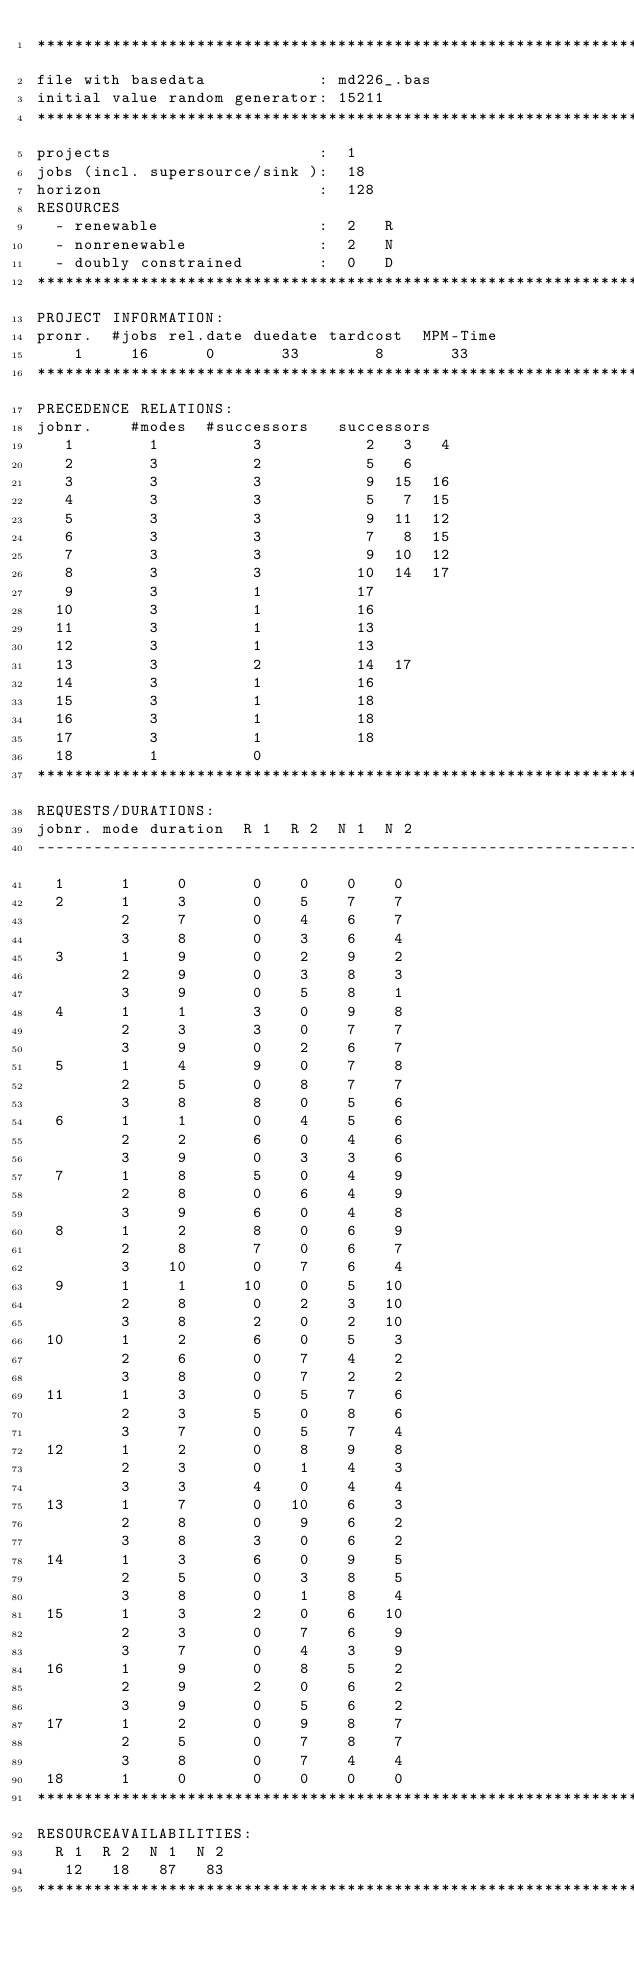<code> <loc_0><loc_0><loc_500><loc_500><_ObjectiveC_>************************************************************************
file with basedata            : md226_.bas
initial value random generator: 15211
************************************************************************
projects                      :  1
jobs (incl. supersource/sink ):  18
horizon                       :  128
RESOURCES
  - renewable                 :  2   R
  - nonrenewable              :  2   N
  - doubly constrained        :  0   D
************************************************************************
PROJECT INFORMATION:
pronr.  #jobs rel.date duedate tardcost  MPM-Time
    1     16      0       33        8       33
************************************************************************
PRECEDENCE RELATIONS:
jobnr.    #modes  #successors   successors
   1        1          3           2   3   4
   2        3          2           5   6
   3        3          3           9  15  16
   4        3          3           5   7  15
   5        3          3           9  11  12
   6        3          3           7   8  15
   7        3          3           9  10  12
   8        3          3          10  14  17
   9        3          1          17
  10        3          1          16
  11        3          1          13
  12        3          1          13
  13        3          2          14  17
  14        3          1          16
  15        3          1          18
  16        3          1          18
  17        3          1          18
  18        1          0        
************************************************************************
REQUESTS/DURATIONS:
jobnr. mode duration  R 1  R 2  N 1  N 2
------------------------------------------------------------------------
  1      1     0       0    0    0    0
  2      1     3       0    5    7    7
         2     7       0    4    6    7
         3     8       0    3    6    4
  3      1     9       0    2    9    2
         2     9       0    3    8    3
         3     9       0    5    8    1
  4      1     1       3    0    9    8
         2     3       3    0    7    7
         3     9       0    2    6    7
  5      1     4       9    0    7    8
         2     5       0    8    7    7
         3     8       8    0    5    6
  6      1     1       0    4    5    6
         2     2       6    0    4    6
         3     9       0    3    3    6
  7      1     8       5    0    4    9
         2     8       0    6    4    9
         3     9       6    0    4    8
  8      1     2       8    0    6    9
         2     8       7    0    6    7
         3    10       0    7    6    4
  9      1     1      10    0    5   10
         2     8       0    2    3   10
         3     8       2    0    2   10
 10      1     2       6    0    5    3
         2     6       0    7    4    2
         3     8       0    7    2    2
 11      1     3       0    5    7    6
         2     3       5    0    8    6
         3     7       0    5    7    4
 12      1     2       0    8    9    8
         2     3       0    1    4    3
         3     3       4    0    4    4
 13      1     7       0   10    6    3
         2     8       0    9    6    2
         3     8       3    0    6    2
 14      1     3       6    0    9    5
         2     5       0    3    8    5
         3     8       0    1    8    4
 15      1     3       2    0    6   10
         2     3       0    7    6    9
         3     7       0    4    3    9
 16      1     9       0    8    5    2
         2     9       2    0    6    2
         3     9       0    5    6    2
 17      1     2       0    9    8    7
         2     5       0    7    8    7
         3     8       0    7    4    4
 18      1     0       0    0    0    0
************************************************************************
RESOURCEAVAILABILITIES:
  R 1  R 2  N 1  N 2
   12   18   87   83
************************************************************************
</code> 